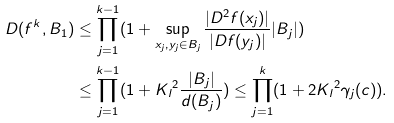Convert formula to latex. <formula><loc_0><loc_0><loc_500><loc_500>D ( f ^ { k } , { B } _ { 1 } ) & \leq \prod _ { j = 1 } ^ { k - 1 } ( 1 + \sup _ { x _ { j } , y _ { j } \in { B } _ { j } } \frac { | D ^ { 2 } f ( x _ { j } ) | } { | D f ( y _ { j } ) | } | B _ { j } | ) \\ & \leq \prod _ { j = 1 } ^ { k - 1 } ( 1 + { K _ { l } } ^ { 2 } \frac { | { B } _ { j } | } { d ( { B } _ { j } ) } ) \leq \prod _ { j = 1 } ^ { k } ( 1 + 2 { K _ { l } } ^ { 2 } \gamma _ { j } ( c ) ) .</formula> 